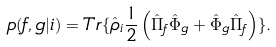<formula> <loc_0><loc_0><loc_500><loc_500>p ( f , g | i ) = T r \{ \hat { \rho } _ { i } \frac { 1 } { 2 } \left ( \hat { \Pi } _ { f } \hat { \Phi } _ { g } + \hat { \Phi } _ { g } \hat { \Pi } _ { f } \right ) \} .</formula> 